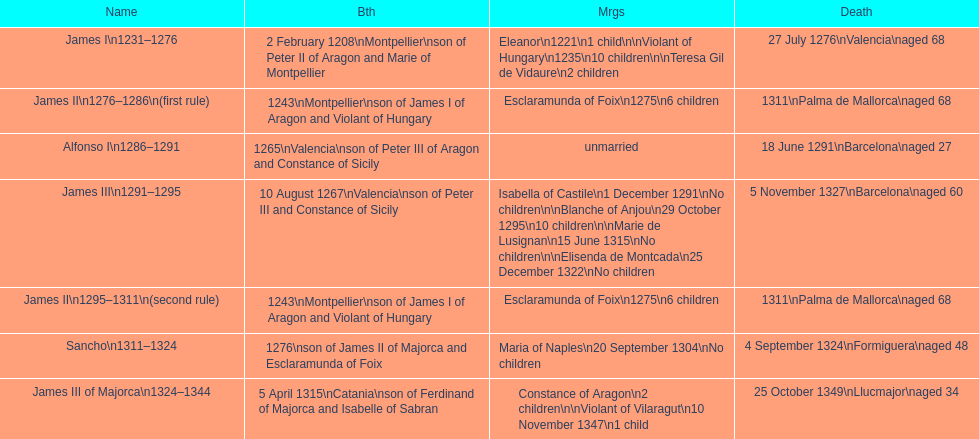Who came to power after the rule of james iii? James II. 